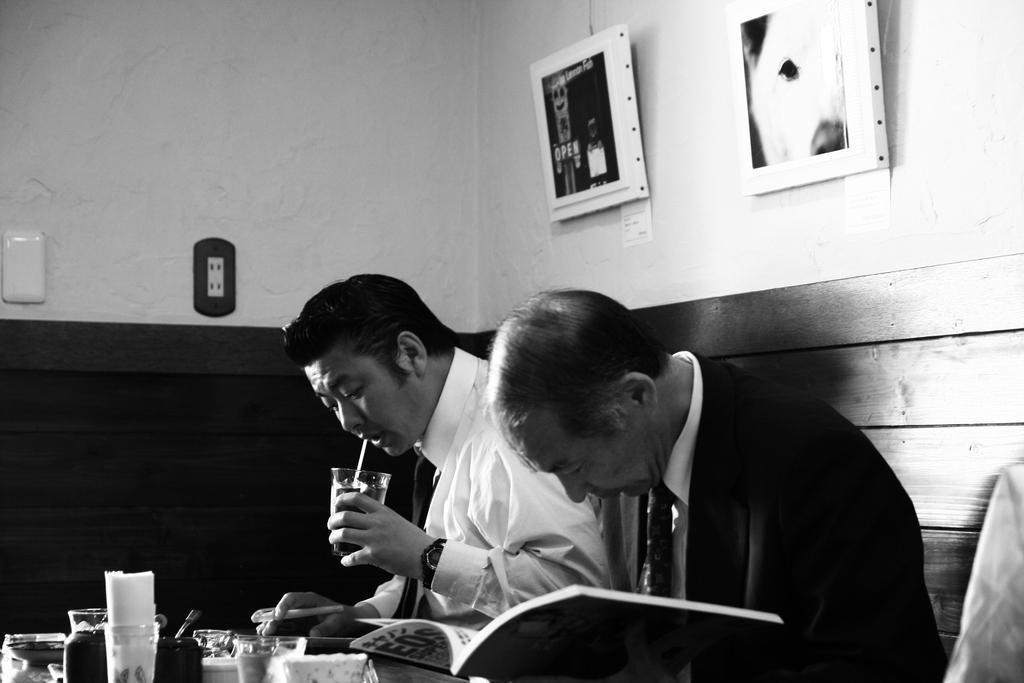Could you give a brief overview of what you see in this image? In the center we can see two persons were sitting around the table. On the table we can see some objects. Coming to background we can see wall and photo frames. 